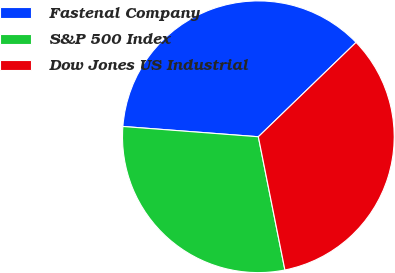Convert chart. <chart><loc_0><loc_0><loc_500><loc_500><pie_chart><fcel>Fastenal Company<fcel>S&P 500 Index<fcel>Dow Jones US Industrial<nl><fcel>36.57%<fcel>29.34%<fcel>34.09%<nl></chart> 